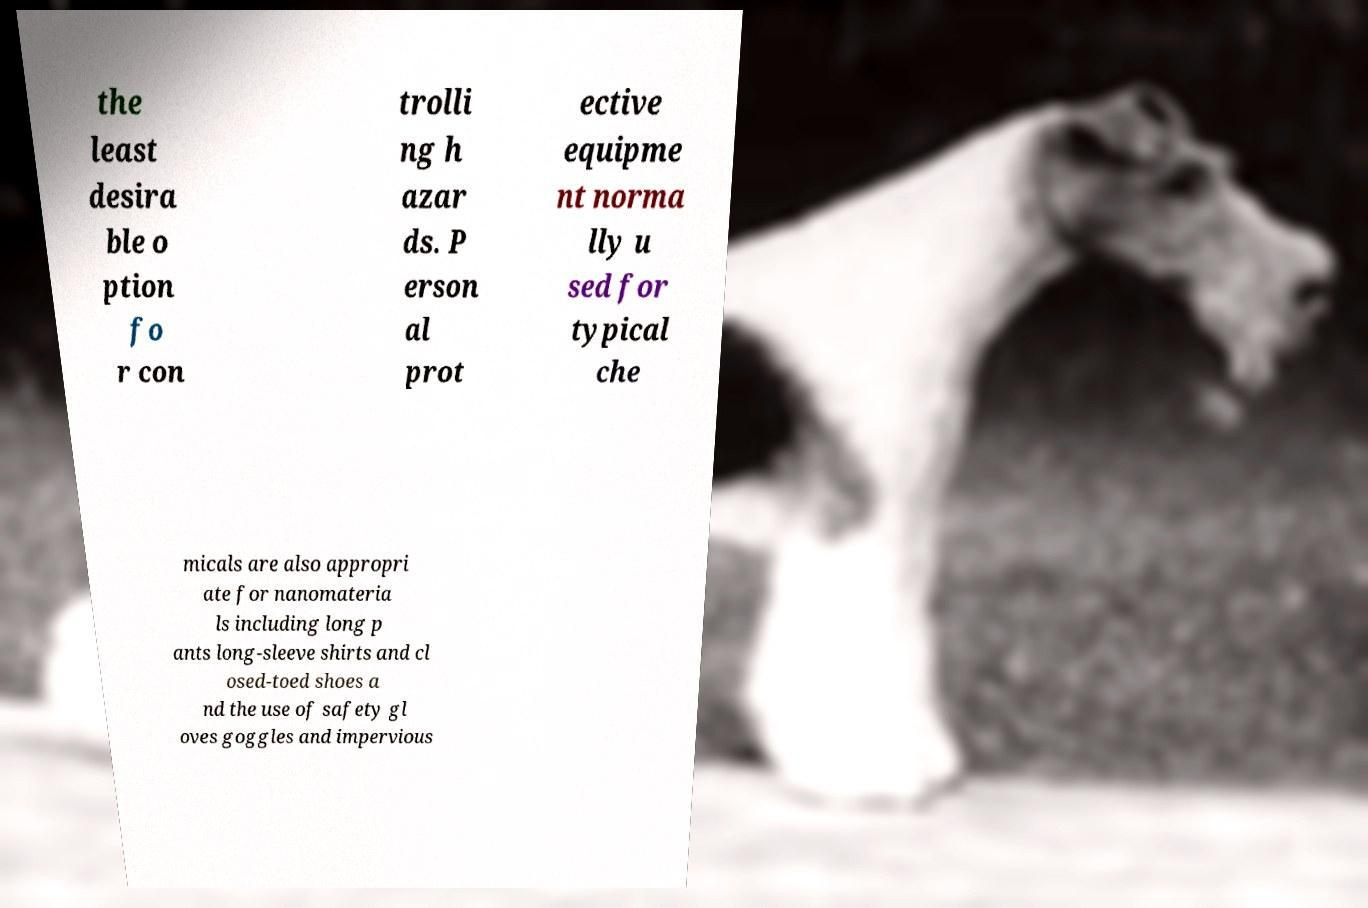There's text embedded in this image that I need extracted. Can you transcribe it verbatim? the least desira ble o ption fo r con trolli ng h azar ds. P erson al prot ective equipme nt norma lly u sed for typical che micals are also appropri ate for nanomateria ls including long p ants long-sleeve shirts and cl osed-toed shoes a nd the use of safety gl oves goggles and impervious 